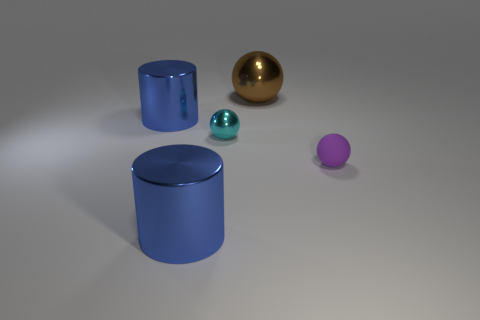What is the size of the blue metal cylinder that is in front of the cyan shiny object?
Offer a terse response. Large. Is there anything else that is the same size as the brown shiny sphere?
Offer a very short reply. Yes. What color is the large shiny thing that is behind the small matte object and in front of the big shiny ball?
Give a very brief answer. Blue. Are the blue thing behind the cyan metal object and the purple ball made of the same material?
Make the answer very short. No. There is a small rubber object; does it have the same color as the small thing left of the rubber object?
Make the answer very short. No. Are there any things to the left of the large brown sphere?
Make the answer very short. Yes. There is a blue shiny object in front of the small cyan metallic object; is it the same size as the metal ball that is left of the large brown sphere?
Provide a short and direct response. No. Is there a object that has the same size as the purple matte ball?
Make the answer very short. Yes. Do the large blue shiny object that is behind the purple object and the purple thing have the same shape?
Provide a short and direct response. No. There is a purple object that is in front of the small shiny thing; what material is it?
Provide a short and direct response. Rubber. 